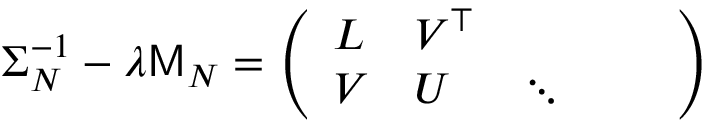<formula> <loc_0><loc_0><loc_500><loc_500>\Sigma _ { N } ^ { - 1 } - \lambda M _ { N } = \left ( \begin{array} { l l l l l } { L } & { V ^ { \top } } \\ { V } & { U } & { \ddots } \end{array} \right )</formula> 